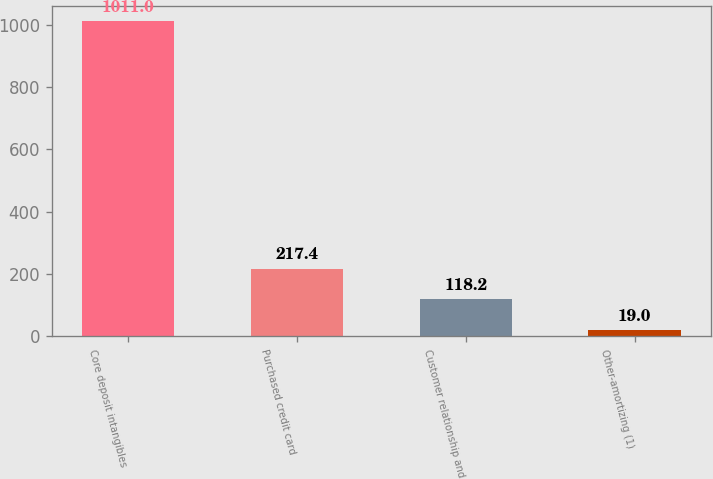Convert chart to OTSL. <chart><loc_0><loc_0><loc_500><loc_500><bar_chart><fcel>Core deposit intangibles<fcel>Purchased credit card<fcel>Customer relationship and<fcel>Other-amortizing (1)<nl><fcel>1011<fcel>217.4<fcel>118.2<fcel>19<nl></chart> 